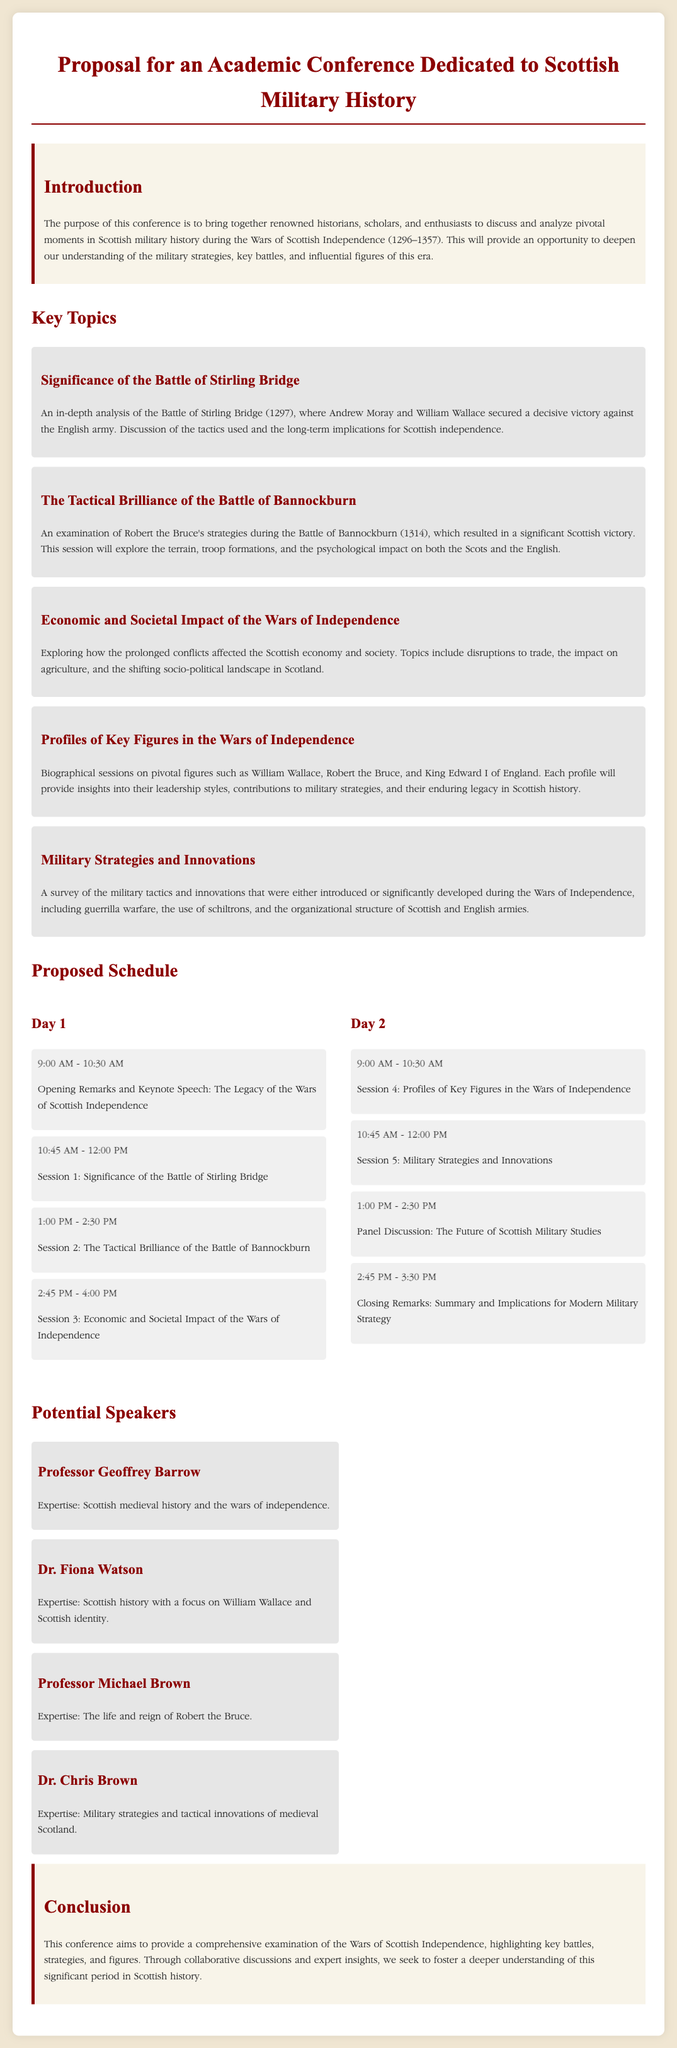What is the title of the proposal? The title of the proposal is the main heading that outlines the document's focus.
Answer: Proposal for an Academic Conference Dedicated to Scottish Military History What are the dates of the Wars of Scottish Independence? The dates are specified as the time period during which the wars occurred.
Answer: 1296–1357 Who delivered the keynote speech? The keynote speech is mentioned in the proposed schedule of Day 1.
Answer: The Legacy of the Wars of Scottish Independence Which battle is analyzed in the first session? The first session's topic provides insight into the battle discussed during this time.
Answer: Battle of Stirling Bridge What is the focus of the second day's first session? The session topics outline the specific historical figures that will be analyzed on the second day.
Answer: Profiles of Key Figures in the Wars of Independence Which key figure is associated with the tactical brilliance during the Battle of Bannockburn? This key figure is highlighted in the session dedicated to examining strategies used in this specific battle.
Answer: Robert the Bruce How many total sessions are scheduled over the two days? The total number includes all listed sessions across both days.
Answer: Six What type of impact does the third topic address? The document specifies the type of consequences explored in the given session.
Answer: Economic and Societal Impact Who is the expertise of Dr. Fiona Watson focused on? This speaker's specialization is noted in the potential speakers section describing their research focus.
Answer: William Wallace and Scottish identity 